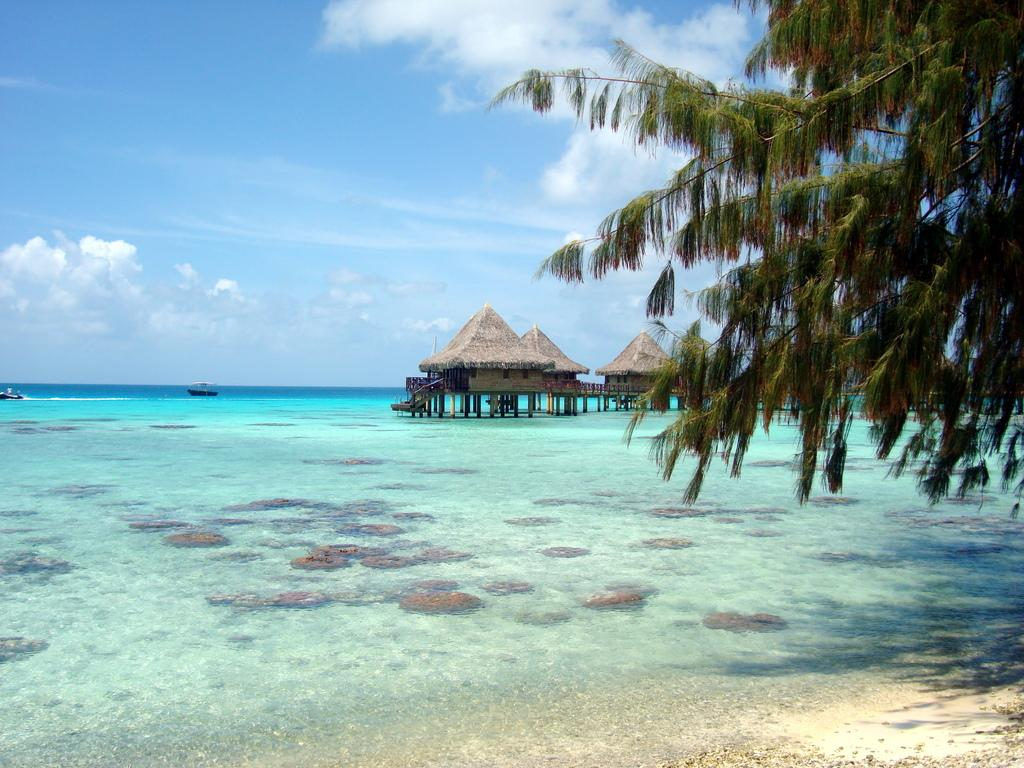What type of vegetation can be seen on the right side of the image? There are leaves on the right side of the image. What structures are located in the center of the image? There are huts in the center of the image. What can be seen in the background of the image? There are boats sailing on the water in the background of the image. How would you describe the sky in the image? The sky is cloudy in the image. How many gates are present in the image? There are no gates visible in the image. What type of table is used by the people in the huts? There is no table present in the image, as it features huts and boats on water. 